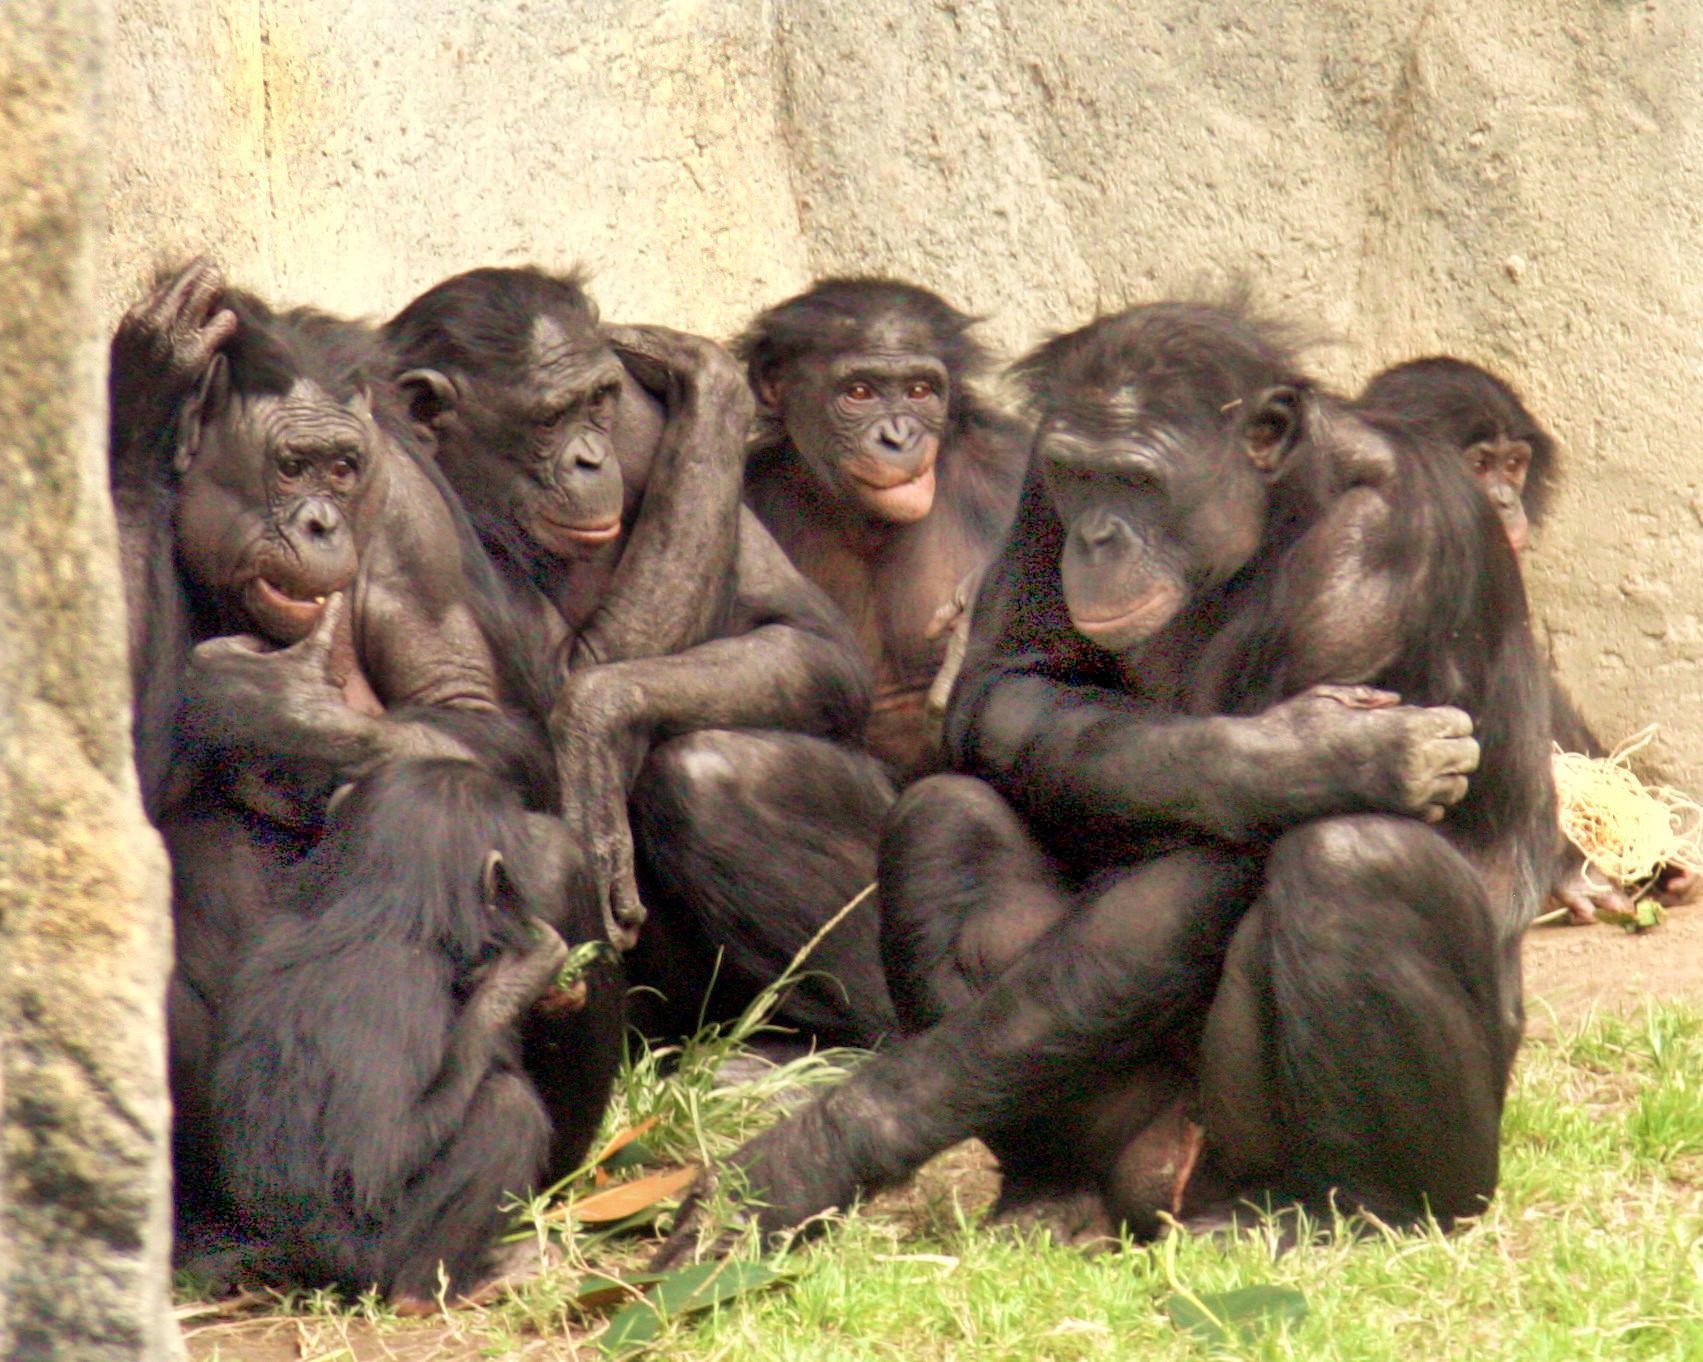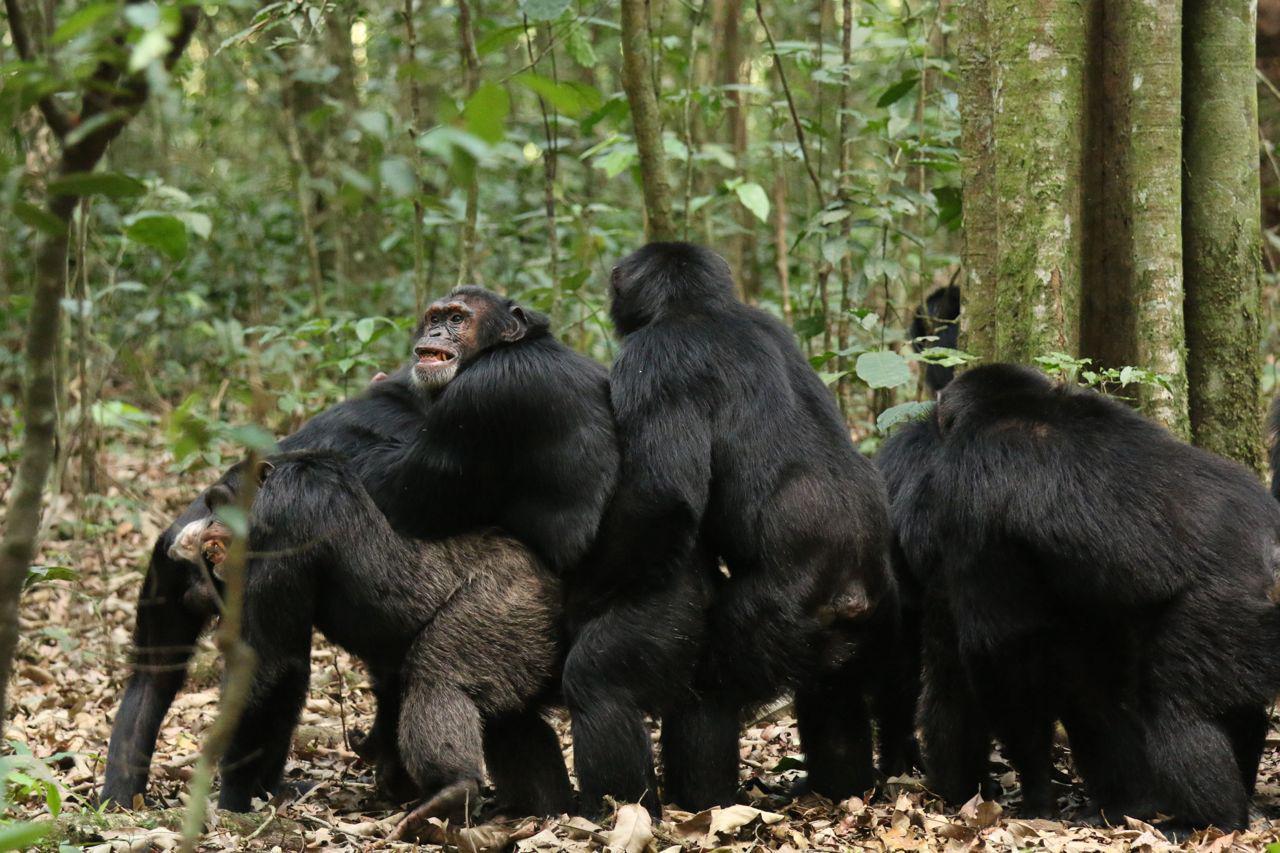The first image is the image on the left, the second image is the image on the right. For the images displayed, is the sentence "At least one image shows a huddle of chimps in physical contact, and an image shows a forward-turned squatting chimp with one arm crossed over the other." factually correct? Answer yes or no. Yes. The first image is the image on the left, the second image is the image on the right. Evaluate the accuracy of this statement regarding the images: "There are more animals in the image on the right.". Is it true? Answer yes or no. No. 